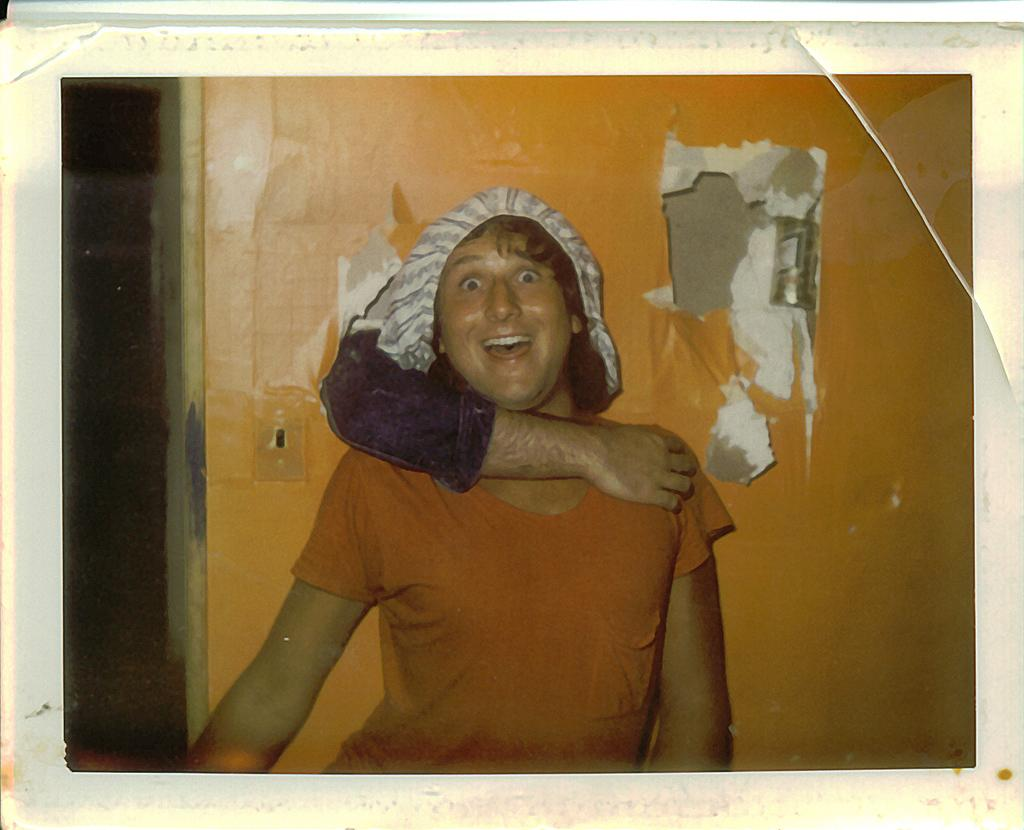What is the main subject of the image? There is a person standing in the image. What is the person's facial expression? The person is smiling. What can be seen behind the person? There is a wall behind the person. How is the person being supported in the image? A hand is holding the person from the wall. What type of fish can be seen swimming near the person in the image? There is no fish present in the image; it features a person standing with a hand holding them from a wall. 